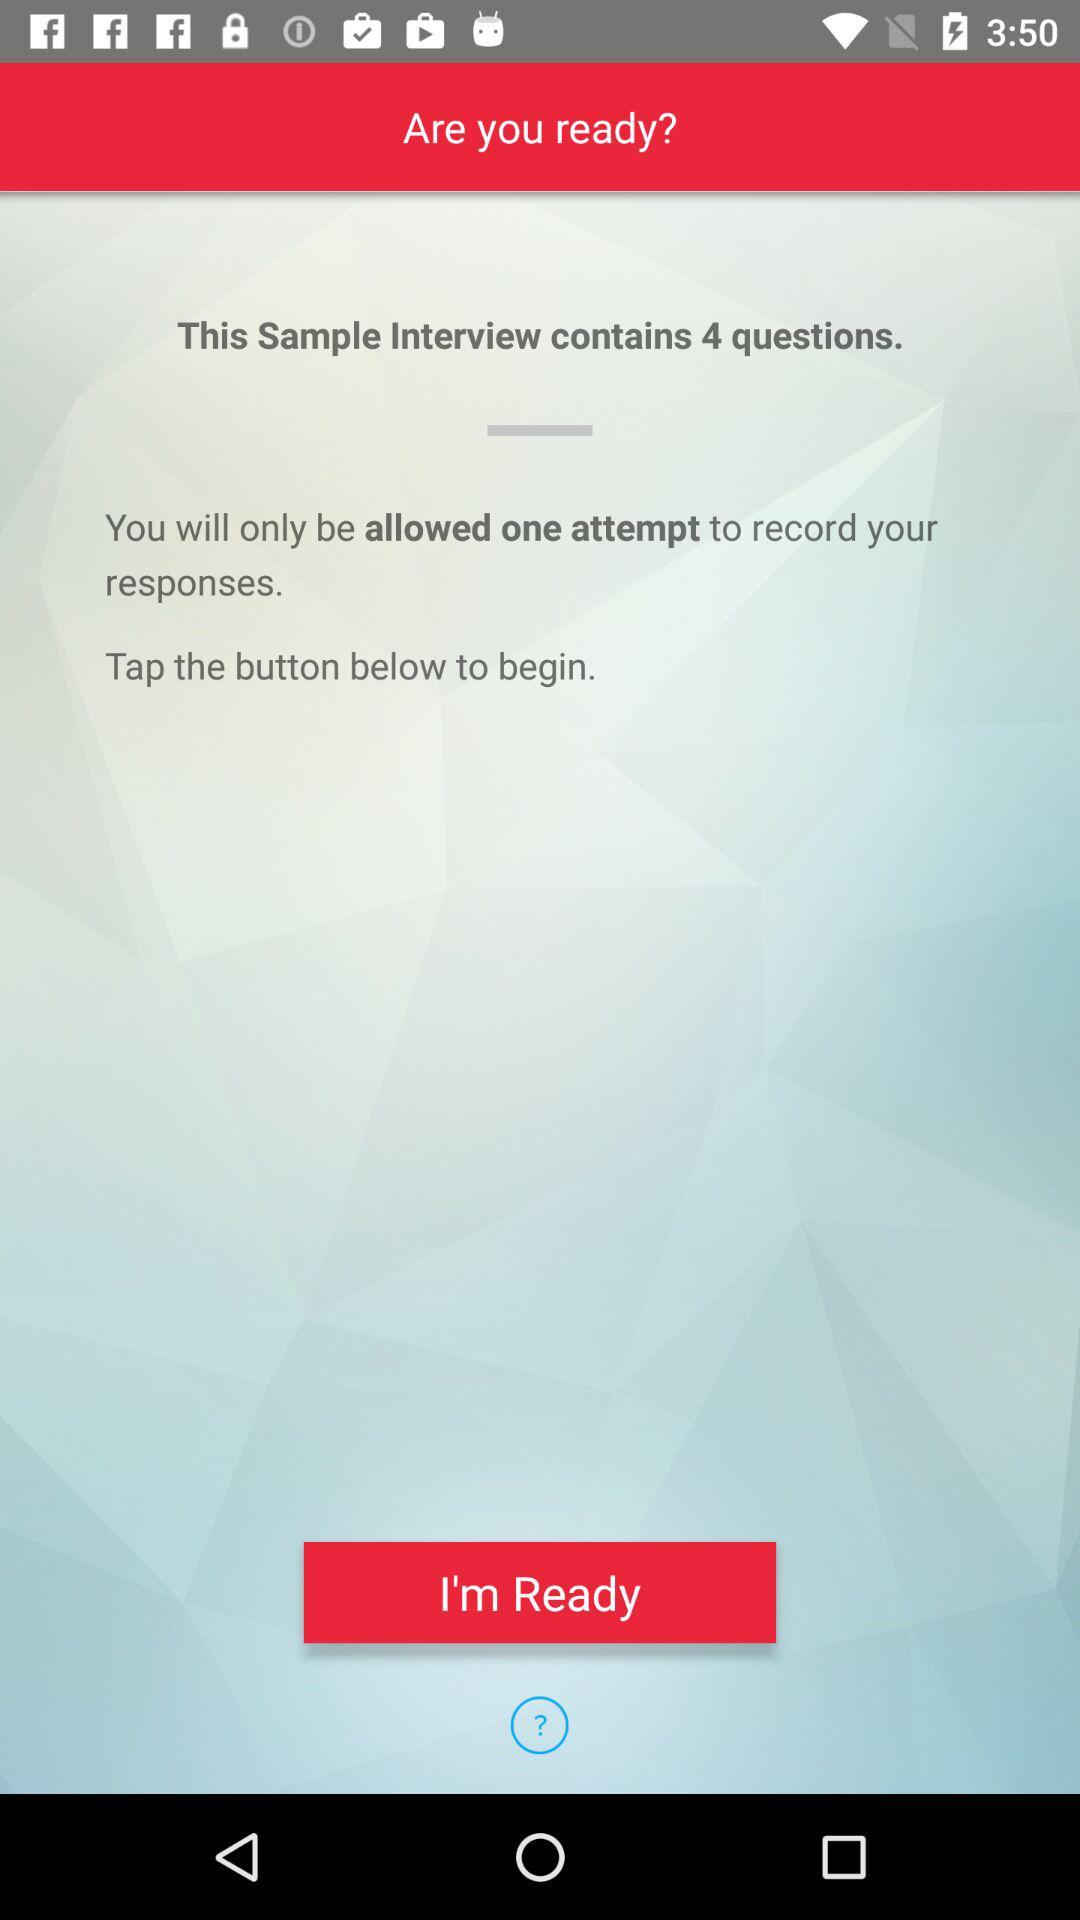How many questions are in this sample interview?
Answer the question using a single word or phrase. 4 